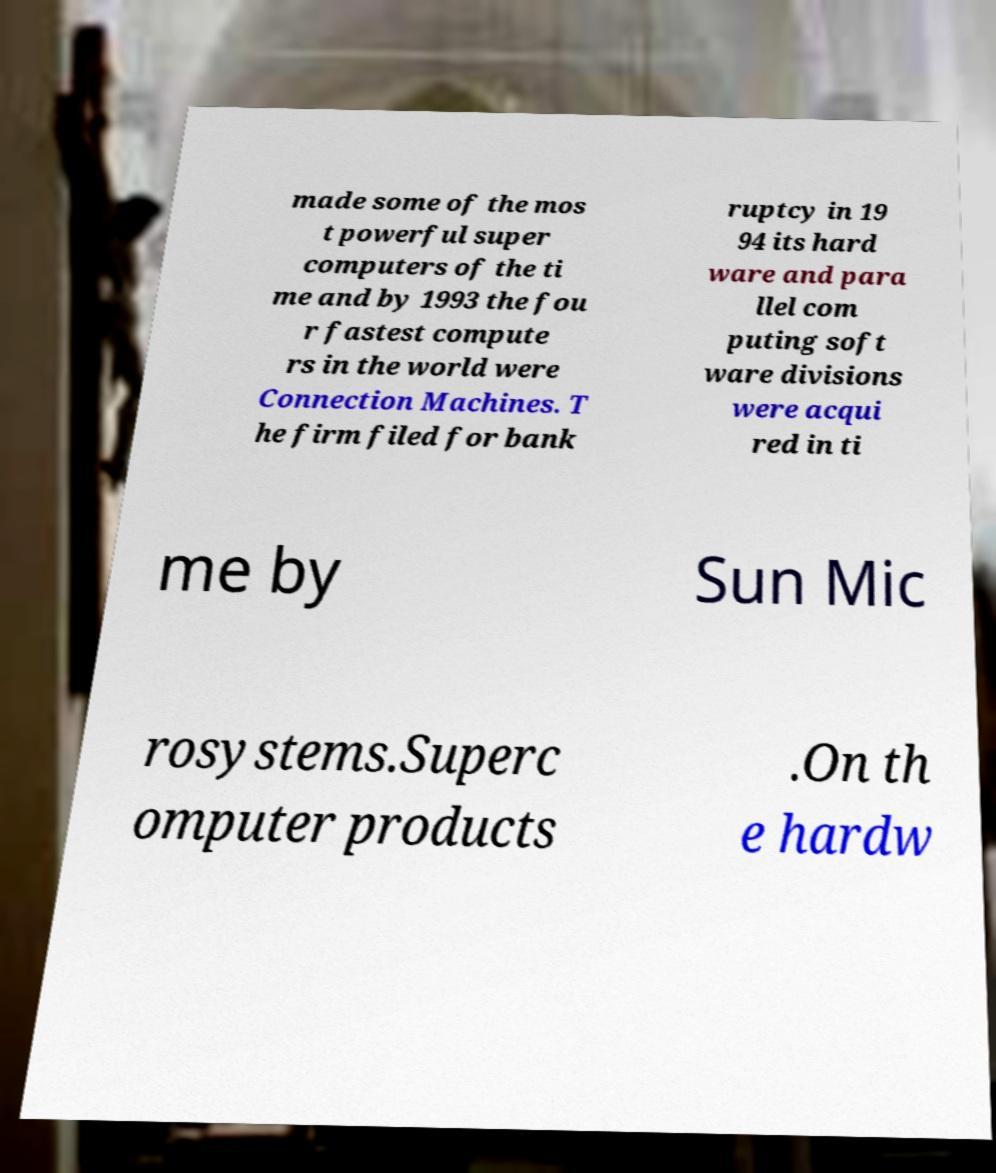Can you read and provide the text displayed in the image?This photo seems to have some interesting text. Can you extract and type it out for me? made some of the mos t powerful super computers of the ti me and by 1993 the fou r fastest compute rs in the world were Connection Machines. T he firm filed for bank ruptcy in 19 94 its hard ware and para llel com puting soft ware divisions were acqui red in ti me by Sun Mic rosystems.Superc omputer products .On th e hardw 